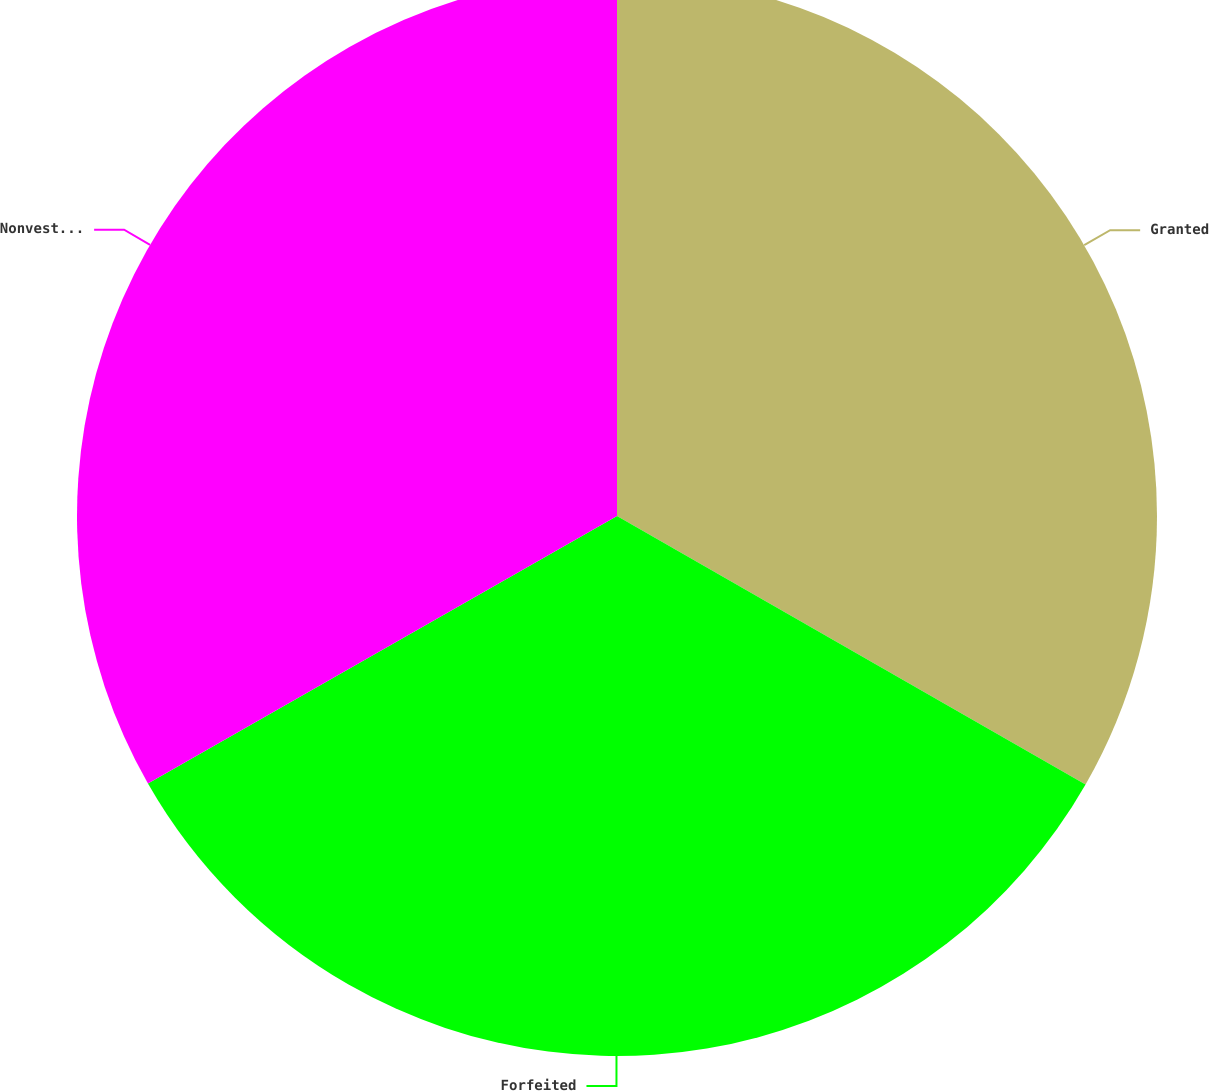Convert chart to OTSL. <chart><loc_0><loc_0><loc_500><loc_500><pie_chart><fcel>Granted<fcel>Forfeited<fcel>Nonvested at December 31 2006<nl><fcel>33.28%<fcel>33.47%<fcel>33.25%<nl></chart> 